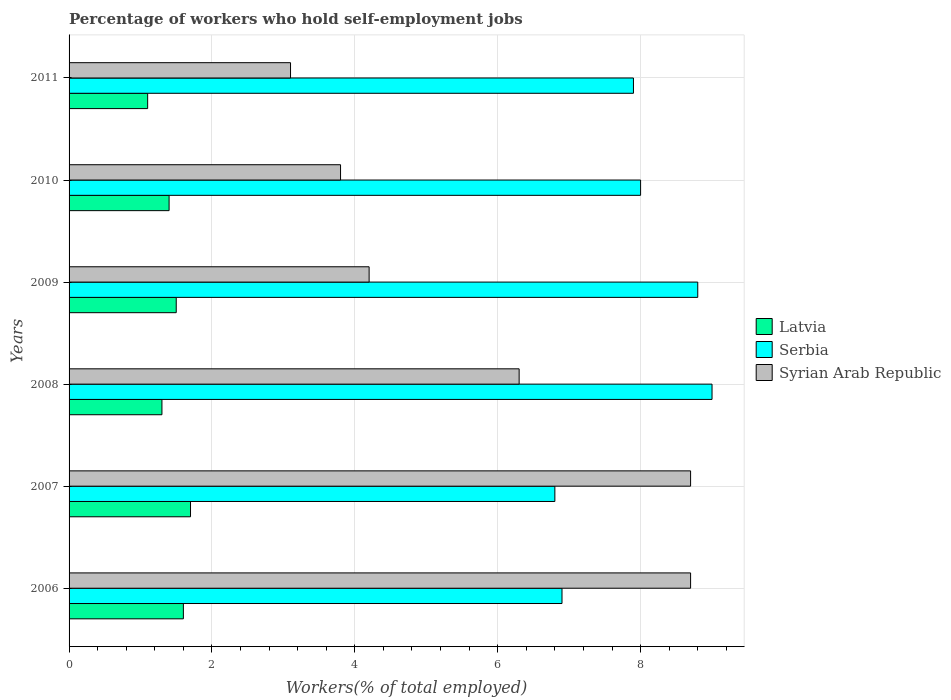Are the number of bars on each tick of the Y-axis equal?
Offer a very short reply. Yes. How many bars are there on the 4th tick from the bottom?
Provide a short and direct response. 3. What is the label of the 1st group of bars from the top?
Give a very brief answer. 2011. In how many cases, is the number of bars for a given year not equal to the number of legend labels?
Make the answer very short. 0. What is the percentage of self-employed workers in Syrian Arab Republic in 2010?
Your response must be concise. 3.8. Across all years, what is the maximum percentage of self-employed workers in Syrian Arab Republic?
Keep it short and to the point. 8.7. Across all years, what is the minimum percentage of self-employed workers in Latvia?
Provide a succinct answer. 1.1. In which year was the percentage of self-employed workers in Syrian Arab Republic maximum?
Give a very brief answer. 2006. In which year was the percentage of self-employed workers in Syrian Arab Republic minimum?
Provide a succinct answer. 2011. What is the total percentage of self-employed workers in Latvia in the graph?
Keep it short and to the point. 8.6. What is the difference between the percentage of self-employed workers in Syrian Arab Republic in 2007 and that in 2010?
Your answer should be very brief. 4.9. What is the difference between the percentage of self-employed workers in Syrian Arab Republic in 2006 and the percentage of self-employed workers in Serbia in 2010?
Your response must be concise. 0.7. What is the average percentage of self-employed workers in Latvia per year?
Give a very brief answer. 1.43. In the year 2007, what is the difference between the percentage of self-employed workers in Latvia and percentage of self-employed workers in Syrian Arab Republic?
Provide a short and direct response. -7. What is the ratio of the percentage of self-employed workers in Serbia in 2007 to that in 2010?
Offer a terse response. 0.85. What is the difference between the highest and the second highest percentage of self-employed workers in Latvia?
Give a very brief answer. 0.1. What is the difference between the highest and the lowest percentage of self-employed workers in Latvia?
Offer a very short reply. 0.6. In how many years, is the percentage of self-employed workers in Latvia greater than the average percentage of self-employed workers in Latvia taken over all years?
Offer a very short reply. 3. What does the 1st bar from the top in 2007 represents?
Provide a short and direct response. Syrian Arab Republic. What does the 3rd bar from the bottom in 2011 represents?
Your answer should be very brief. Syrian Arab Republic. Is it the case that in every year, the sum of the percentage of self-employed workers in Serbia and percentage of self-employed workers in Latvia is greater than the percentage of self-employed workers in Syrian Arab Republic?
Provide a succinct answer. No. How many bars are there?
Your response must be concise. 18. Are all the bars in the graph horizontal?
Your response must be concise. Yes. How many years are there in the graph?
Provide a short and direct response. 6. What is the difference between two consecutive major ticks on the X-axis?
Provide a short and direct response. 2. Are the values on the major ticks of X-axis written in scientific E-notation?
Provide a succinct answer. No. Does the graph contain grids?
Keep it short and to the point. Yes. Where does the legend appear in the graph?
Your answer should be very brief. Center right. How many legend labels are there?
Keep it short and to the point. 3. What is the title of the graph?
Your answer should be compact. Percentage of workers who hold self-employment jobs. What is the label or title of the X-axis?
Ensure brevity in your answer.  Workers(% of total employed). What is the label or title of the Y-axis?
Offer a terse response. Years. What is the Workers(% of total employed) of Latvia in 2006?
Offer a very short reply. 1.6. What is the Workers(% of total employed) in Serbia in 2006?
Ensure brevity in your answer.  6.9. What is the Workers(% of total employed) of Syrian Arab Republic in 2006?
Keep it short and to the point. 8.7. What is the Workers(% of total employed) of Latvia in 2007?
Provide a short and direct response. 1.7. What is the Workers(% of total employed) of Serbia in 2007?
Give a very brief answer. 6.8. What is the Workers(% of total employed) in Syrian Arab Republic in 2007?
Offer a terse response. 8.7. What is the Workers(% of total employed) in Latvia in 2008?
Your response must be concise. 1.3. What is the Workers(% of total employed) in Serbia in 2008?
Provide a succinct answer. 9. What is the Workers(% of total employed) of Syrian Arab Republic in 2008?
Ensure brevity in your answer.  6.3. What is the Workers(% of total employed) in Serbia in 2009?
Your response must be concise. 8.8. What is the Workers(% of total employed) in Syrian Arab Republic in 2009?
Keep it short and to the point. 4.2. What is the Workers(% of total employed) of Latvia in 2010?
Make the answer very short. 1.4. What is the Workers(% of total employed) of Syrian Arab Republic in 2010?
Ensure brevity in your answer.  3.8. What is the Workers(% of total employed) in Latvia in 2011?
Offer a very short reply. 1.1. What is the Workers(% of total employed) of Serbia in 2011?
Ensure brevity in your answer.  7.9. What is the Workers(% of total employed) of Syrian Arab Republic in 2011?
Keep it short and to the point. 3.1. Across all years, what is the maximum Workers(% of total employed) in Latvia?
Your answer should be very brief. 1.7. Across all years, what is the maximum Workers(% of total employed) of Syrian Arab Republic?
Ensure brevity in your answer.  8.7. Across all years, what is the minimum Workers(% of total employed) in Latvia?
Keep it short and to the point. 1.1. Across all years, what is the minimum Workers(% of total employed) in Serbia?
Your answer should be very brief. 6.8. Across all years, what is the minimum Workers(% of total employed) in Syrian Arab Republic?
Ensure brevity in your answer.  3.1. What is the total Workers(% of total employed) in Latvia in the graph?
Your answer should be compact. 8.6. What is the total Workers(% of total employed) of Serbia in the graph?
Provide a short and direct response. 47.4. What is the total Workers(% of total employed) in Syrian Arab Republic in the graph?
Keep it short and to the point. 34.8. What is the difference between the Workers(% of total employed) in Serbia in 2006 and that in 2007?
Give a very brief answer. 0.1. What is the difference between the Workers(% of total employed) of Latvia in 2006 and that in 2008?
Make the answer very short. 0.3. What is the difference between the Workers(% of total employed) of Syrian Arab Republic in 2006 and that in 2008?
Make the answer very short. 2.4. What is the difference between the Workers(% of total employed) of Syrian Arab Republic in 2006 and that in 2010?
Make the answer very short. 4.9. What is the difference between the Workers(% of total employed) in Serbia in 2006 and that in 2011?
Offer a very short reply. -1. What is the difference between the Workers(% of total employed) in Latvia in 2007 and that in 2008?
Provide a succinct answer. 0.4. What is the difference between the Workers(% of total employed) in Latvia in 2007 and that in 2009?
Ensure brevity in your answer.  0.2. What is the difference between the Workers(% of total employed) in Serbia in 2007 and that in 2010?
Your response must be concise. -1.2. What is the difference between the Workers(% of total employed) of Latvia in 2007 and that in 2011?
Provide a short and direct response. 0.6. What is the difference between the Workers(% of total employed) in Latvia in 2008 and that in 2009?
Provide a short and direct response. -0.2. What is the difference between the Workers(% of total employed) of Serbia in 2008 and that in 2009?
Offer a terse response. 0.2. What is the difference between the Workers(% of total employed) in Serbia in 2008 and that in 2010?
Provide a succinct answer. 1. What is the difference between the Workers(% of total employed) in Serbia in 2008 and that in 2011?
Keep it short and to the point. 1.1. What is the difference between the Workers(% of total employed) of Syrian Arab Republic in 2010 and that in 2011?
Keep it short and to the point. 0.7. What is the difference between the Workers(% of total employed) of Latvia in 2006 and the Workers(% of total employed) of Syrian Arab Republic in 2007?
Ensure brevity in your answer.  -7.1. What is the difference between the Workers(% of total employed) in Serbia in 2006 and the Workers(% of total employed) in Syrian Arab Republic in 2007?
Provide a succinct answer. -1.8. What is the difference between the Workers(% of total employed) of Latvia in 2006 and the Workers(% of total employed) of Syrian Arab Republic in 2008?
Your answer should be very brief. -4.7. What is the difference between the Workers(% of total employed) in Serbia in 2006 and the Workers(% of total employed) in Syrian Arab Republic in 2008?
Make the answer very short. 0.6. What is the difference between the Workers(% of total employed) of Latvia in 2006 and the Workers(% of total employed) of Serbia in 2009?
Keep it short and to the point. -7.2. What is the difference between the Workers(% of total employed) of Latvia in 2006 and the Workers(% of total employed) of Syrian Arab Republic in 2009?
Your response must be concise. -2.6. What is the difference between the Workers(% of total employed) in Serbia in 2006 and the Workers(% of total employed) in Syrian Arab Republic in 2010?
Offer a very short reply. 3.1. What is the difference between the Workers(% of total employed) of Latvia in 2006 and the Workers(% of total employed) of Syrian Arab Republic in 2011?
Offer a terse response. -1.5. What is the difference between the Workers(% of total employed) in Serbia in 2006 and the Workers(% of total employed) in Syrian Arab Republic in 2011?
Provide a short and direct response. 3.8. What is the difference between the Workers(% of total employed) of Latvia in 2007 and the Workers(% of total employed) of Syrian Arab Republic in 2008?
Provide a succinct answer. -4.6. What is the difference between the Workers(% of total employed) of Latvia in 2007 and the Workers(% of total employed) of Serbia in 2009?
Ensure brevity in your answer.  -7.1. What is the difference between the Workers(% of total employed) in Latvia in 2007 and the Workers(% of total employed) in Serbia in 2010?
Your response must be concise. -6.3. What is the difference between the Workers(% of total employed) in Latvia in 2007 and the Workers(% of total employed) in Syrian Arab Republic in 2010?
Provide a succinct answer. -2.1. What is the difference between the Workers(% of total employed) in Serbia in 2007 and the Workers(% of total employed) in Syrian Arab Republic in 2010?
Offer a terse response. 3. What is the difference between the Workers(% of total employed) in Latvia in 2007 and the Workers(% of total employed) in Serbia in 2011?
Provide a short and direct response. -6.2. What is the difference between the Workers(% of total employed) of Serbia in 2007 and the Workers(% of total employed) of Syrian Arab Republic in 2011?
Your answer should be very brief. 3.7. What is the difference between the Workers(% of total employed) in Latvia in 2008 and the Workers(% of total employed) in Syrian Arab Republic in 2009?
Make the answer very short. -2.9. What is the difference between the Workers(% of total employed) of Serbia in 2008 and the Workers(% of total employed) of Syrian Arab Republic in 2010?
Make the answer very short. 5.2. What is the difference between the Workers(% of total employed) in Latvia in 2008 and the Workers(% of total employed) in Serbia in 2011?
Ensure brevity in your answer.  -6.6. What is the difference between the Workers(% of total employed) of Serbia in 2008 and the Workers(% of total employed) of Syrian Arab Republic in 2011?
Your answer should be compact. 5.9. What is the difference between the Workers(% of total employed) of Serbia in 2009 and the Workers(% of total employed) of Syrian Arab Republic in 2010?
Your answer should be very brief. 5. What is the difference between the Workers(% of total employed) in Latvia in 2009 and the Workers(% of total employed) in Serbia in 2011?
Make the answer very short. -6.4. What is the difference between the Workers(% of total employed) of Latvia in 2009 and the Workers(% of total employed) of Syrian Arab Republic in 2011?
Make the answer very short. -1.6. What is the difference between the Workers(% of total employed) in Serbia in 2009 and the Workers(% of total employed) in Syrian Arab Republic in 2011?
Provide a succinct answer. 5.7. What is the difference between the Workers(% of total employed) of Latvia in 2010 and the Workers(% of total employed) of Serbia in 2011?
Provide a succinct answer. -6.5. What is the difference between the Workers(% of total employed) in Serbia in 2010 and the Workers(% of total employed) in Syrian Arab Republic in 2011?
Offer a very short reply. 4.9. What is the average Workers(% of total employed) in Latvia per year?
Ensure brevity in your answer.  1.43. What is the average Workers(% of total employed) in Serbia per year?
Offer a very short reply. 7.9. In the year 2006, what is the difference between the Workers(% of total employed) of Latvia and Workers(% of total employed) of Serbia?
Offer a very short reply. -5.3. In the year 2006, what is the difference between the Workers(% of total employed) in Serbia and Workers(% of total employed) in Syrian Arab Republic?
Offer a terse response. -1.8. In the year 2008, what is the difference between the Workers(% of total employed) in Latvia and Workers(% of total employed) in Serbia?
Offer a terse response. -7.7. In the year 2009, what is the difference between the Workers(% of total employed) in Latvia and Workers(% of total employed) in Serbia?
Your answer should be very brief. -7.3. In the year 2010, what is the difference between the Workers(% of total employed) of Latvia and Workers(% of total employed) of Syrian Arab Republic?
Ensure brevity in your answer.  -2.4. In the year 2010, what is the difference between the Workers(% of total employed) in Serbia and Workers(% of total employed) in Syrian Arab Republic?
Provide a short and direct response. 4.2. In the year 2011, what is the difference between the Workers(% of total employed) of Latvia and Workers(% of total employed) of Serbia?
Your answer should be compact. -6.8. In the year 2011, what is the difference between the Workers(% of total employed) in Latvia and Workers(% of total employed) in Syrian Arab Republic?
Offer a terse response. -2. In the year 2011, what is the difference between the Workers(% of total employed) of Serbia and Workers(% of total employed) of Syrian Arab Republic?
Your answer should be very brief. 4.8. What is the ratio of the Workers(% of total employed) of Serbia in 2006 to that in 2007?
Offer a very short reply. 1.01. What is the ratio of the Workers(% of total employed) in Syrian Arab Republic in 2006 to that in 2007?
Give a very brief answer. 1. What is the ratio of the Workers(% of total employed) in Latvia in 2006 to that in 2008?
Keep it short and to the point. 1.23. What is the ratio of the Workers(% of total employed) in Serbia in 2006 to that in 2008?
Keep it short and to the point. 0.77. What is the ratio of the Workers(% of total employed) of Syrian Arab Republic in 2006 to that in 2008?
Offer a very short reply. 1.38. What is the ratio of the Workers(% of total employed) of Latvia in 2006 to that in 2009?
Provide a succinct answer. 1.07. What is the ratio of the Workers(% of total employed) of Serbia in 2006 to that in 2009?
Give a very brief answer. 0.78. What is the ratio of the Workers(% of total employed) of Syrian Arab Republic in 2006 to that in 2009?
Offer a terse response. 2.07. What is the ratio of the Workers(% of total employed) of Latvia in 2006 to that in 2010?
Your answer should be compact. 1.14. What is the ratio of the Workers(% of total employed) in Serbia in 2006 to that in 2010?
Ensure brevity in your answer.  0.86. What is the ratio of the Workers(% of total employed) of Syrian Arab Republic in 2006 to that in 2010?
Provide a short and direct response. 2.29. What is the ratio of the Workers(% of total employed) of Latvia in 2006 to that in 2011?
Keep it short and to the point. 1.45. What is the ratio of the Workers(% of total employed) in Serbia in 2006 to that in 2011?
Your answer should be very brief. 0.87. What is the ratio of the Workers(% of total employed) in Syrian Arab Republic in 2006 to that in 2011?
Your answer should be very brief. 2.81. What is the ratio of the Workers(% of total employed) in Latvia in 2007 to that in 2008?
Provide a succinct answer. 1.31. What is the ratio of the Workers(% of total employed) in Serbia in 2007 to that in 2008?
Provide a short and direct response. 0.76. What is the ratio of the Workers(% of total employed) in Syrian Arab Republic in 2007 to that in 2008?
Give a very brief answer. 1.38. What is the ratio of the Workers(% of total employed) in Latvia in 2007 to that in 2009?
Keep it short and to the point. 1.13. What is the ratio of the Workers(% of total employed) in Serbia in 2007 to that in 2009?
Offer a terse response. 0.77. What is the ratio of the Workers(% of total employed) in Syrian Arab Republic in 2007 to that in 2009?
Your answer should be compact. 2.07. What is the ratio of the Workers(% of total employed) in Latvia in 2007 to that in 2010?
Your response must be concise. 1.21. What is the ratio of the Workers(% of total employed) of Serbia in 2007 to that in 2010?
Provide a succinct answer. 0.85. What is the ratio of the Workers(% of total employed) of Syrian Arab Republic in 2007 to that in 2010?
Your answer should be very brief. 2.29. What is the ratio of the Workers(% of total employed) in Latvia in 2007 to that in 2011?
Your answer should be compact. 1.55. What is the ratio of the Workers(% of total employed) of Serbia in 2007 to that in 2011?
Ensure brevity in your answer.  0.86. What is the ratio of the Workers(% of total employed) of Syrian Arab Republic in 2007 to that in 2011?
Offer a terse response. 2.81. What is the ratio of the Workers(% of total employed) in Latvia in 2008 to that in 2009?
Your response must be concise. 0.87. What is the ratio of the Workers(% of total employed) in Serbia in 2008 to that in 2009?
Your answer should be compact. 1.02. What is the ratio of the Workers(% of total employed) in Syrian Arab Republic in 2008 to that in 2010?
Keep it short and to the point. 1.66. What is the ratio of the Workers(% of total employed) of Latvia in 2008 to that in 2011?
Provide a succinct answer. 1.18. What is the ratio of the Workers(% of total employed) in Serbia in 2008 to that in 2011?
Keep it short and to the point. 1.14. What is the ratio of the Workers(% of total employed) of Syrian Arab Republic in 2008 to that in 2011?
Your answer should be very brief. 2.03. What is the ratio of the Workers(% of total employed) in Latvia in 2009 to that in 2010?
Your answer should be compact. 1.07. What is the ratio of the Workers(% of total employed) of Serbia in 2009 to that in 2010?
Your answer should be compact. 1.1. What is the ratio of the Workers(% of total employed) in Syrian Arab Republic in 2009 to that in 2010?
Your answer should be very brief. 1.11. What is the ratio of the Workers(% of total employed) in Latvia in 2009 to that in 2011?
Offer a very short reply. 1.36. What is the ratio of the Workers(% of total employed) in Serbia in 2009 to that in 2011?
Ensure brevity in your answer.  1.11. What is the ratio of the Workers(% of total employed) of Syrian Arab Republic in 2009 to that in 2011?
Your response must be concise. 1.35. What is the ratio of the Workers(% of total employed) in Latvia in 2010 to that in 2011?
Provide a succinct answer. 1.27. What is the ratio of the Workers(% of total employed) of Serbia in 2010 to that in 2011?
Offer a very short reply. 1.01. What is the ratio of the Workers(% of total employed) of Syrian Arab Republic in 2010 to that in 2011?
Make the answer very short. 1.23. What is the difference between the highest and the second highest Workers(% of total employed) in Serbia?
Keep it short and to the point. 0.2. What is the difference between the highest and the second highest Workers(% of total employed) of Syrian Arab Republic?
Provide a short and direct response. 0. What is the difference between the highest and the lowest Workers(% of total employed) of Serbia?
Your answer should be compact. 2.2. What is the difference between the highest and the lowest Workers(% of total employed) in Syrian Arab Republic?
Your response must be concise. 5.6. 